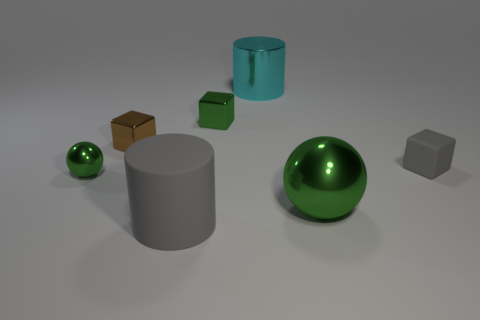Are there any other things that have the same shape as the brown shiny thing?
Your response must be concise. Yes. There is another tiny matte object that is the same shape as the small brown thing; what color is it?
Provide a short and direct response. Gray. How big is the brown metal cube?
Your answer should be very brief. Small. Is the number of matte blocks behind the big cyan object less than the number of metal balls?
Keep it short and to the point. Yes. Do the large green ball and the tiny gray block behind the tiny green metallic sphere have the same material?
Offer a very short reply. No. Are there any metallic balls that are to the left of the green metallic object that is on the right side of the cyan shiny object that is behind the brown metal thing?
Your response must be concise. Yes. Are there any other things that are the same size as the gray rubber cube?
Offer a terse response. Yes. What is the color of the big ball that is made of the same material as the large cyan thing?
Your response must be concise. Green. There is a metallic object that is both in front of the gray matte block and to the left of the cyan metal cylinder; what is its size?
Provide a short and direct response. Small. Are there fewer big cyan shiny things right of the gray matte block than small brown metallic blocks right of the big green metallic sphere?
Provide a short and direct response. No. 